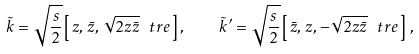<formula> <loc_0><loc_0><loc_500><loc_500>\tilde { k } = \sqrt { \frac { s } { 2 } } \left [ \, z , \, \bar { z } , \, \sqrt { 2 z \bar { z } } \, \ t r { e } \, \right ] , \quad \tilde { k } ^ { \prime } = \sqrt { \frac { s } { 2 } } \left [ \, \bar { z } , \, z , \, - \sqrt { 2 z \bar { z } } \, \ t r { e } \, \right ] \, ,</formula> 